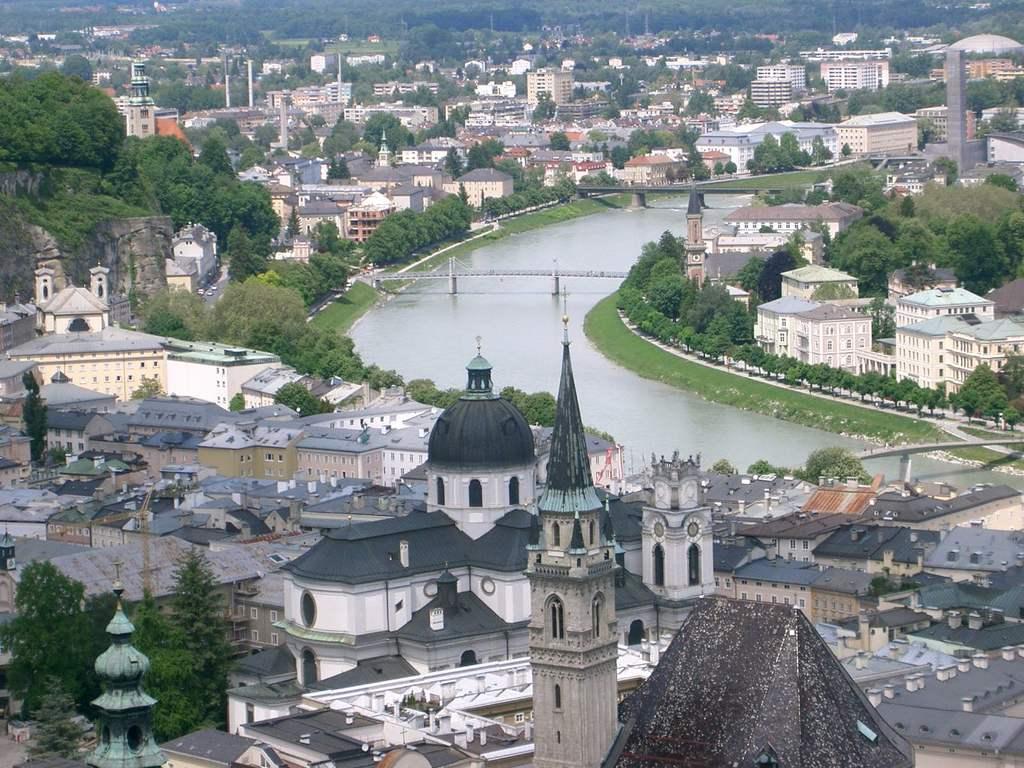Describe this image in one or two sentences. In this image, we can see some trees and buildings. There are canal bridges in the middle of the image. There is an another bridge on the right side of the image. 